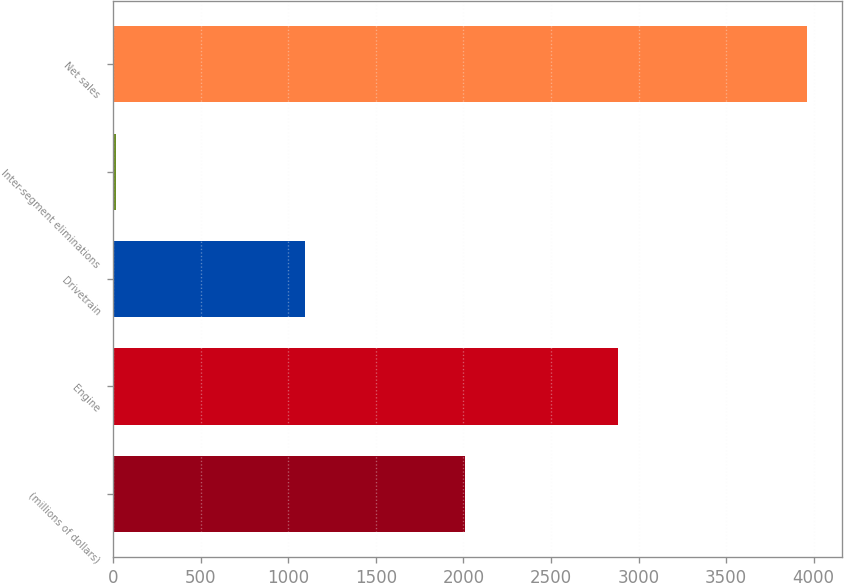<chart> <loc_0><loc_0><loc_500><loc_500><bar_chart><fcel>(millions of dollars)<fcel>Engine<fcel>Drivetrain<fcel>Inter-segment eliminations<fcel>Net sales<nl><fcel>2009<fcel>2883.2<fcel>1093.5<fcel>14.9<fcel>3961.8<nl></chart> 